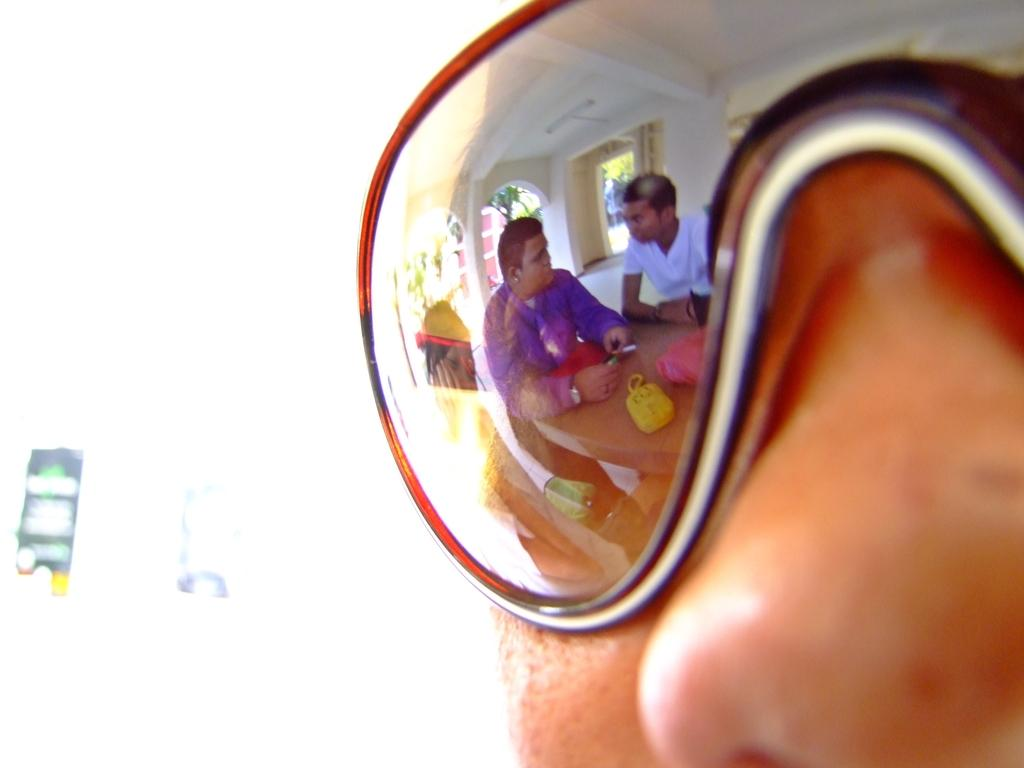What is the main subject of the image? There is a person in the image. Can you describe the person's appearance? The person is wearing glasses. What can be seen in the reflection on the glasses? There is a reflection of people sitting around a table on the glasses. What type of juice is being served at the table in the reflection on the glasses? There is no mention of juice or any specific beverage being served at the table in the reflection on the glasses. 